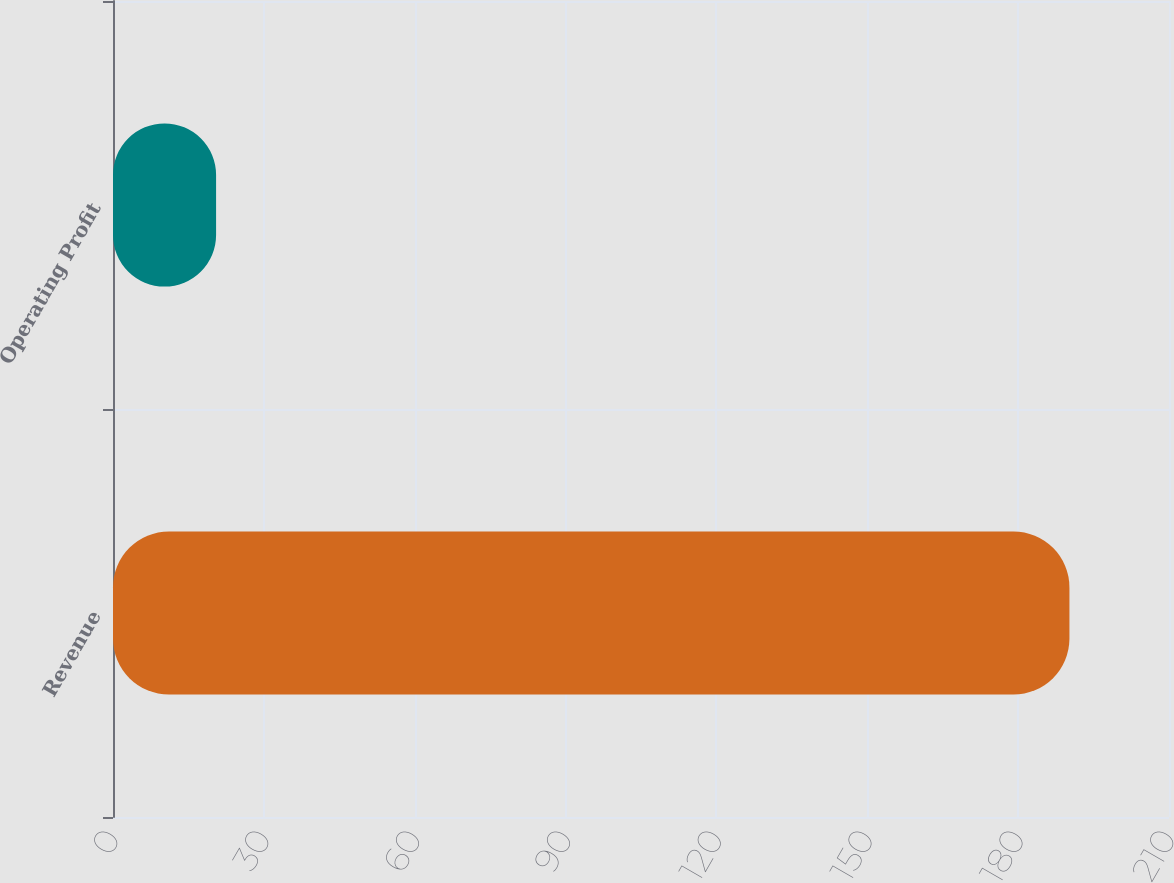Convert chart. <chart><loc_0><loc_0><loc_500><loc_500><bar_chart><fcel>Revenue<fcel>Operating Profit<nl><fcel>190.2<fcel>20.5<nl></chart> 